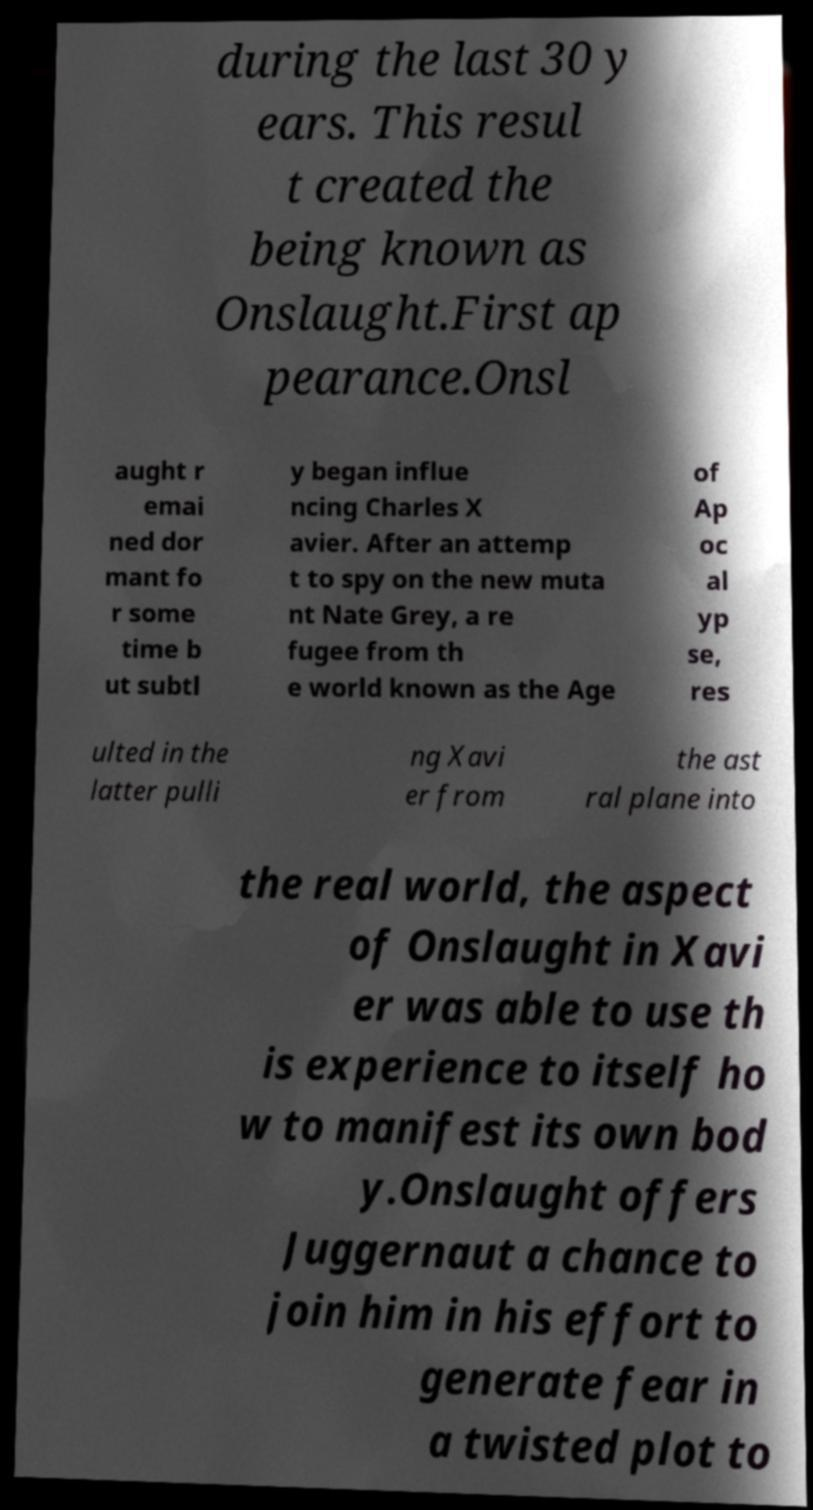What messages or text are displayed in this image? I need them in a readable, typed format. during the last 30 y ears. This resul t created the being known as Onslaught.First ap pearance.Onsl aught r emai ned dor mant fo r some time b ut subtl y began influe ncing Charles X avier. After an attemp t to spy on the new muta nt Nate Grey, a re fugee from th e world known as the Age of Ap oc al yp se, res ulted in the latter pulli ng Xavi er from the ast ral plane into the real world, the aspect of Onslaught in Xavi er was able to use th is experience to itself ho w to manifest its own bod y.Onslaught offers Juggernaut a chance to join him in his effort to generate fear in a twisted plot to 